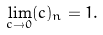<formula> <loc_0><loc_0><loc_500><loc_500>\lim _ { c \to 0 } ( c ) _ { n } = 1 .</formula> 